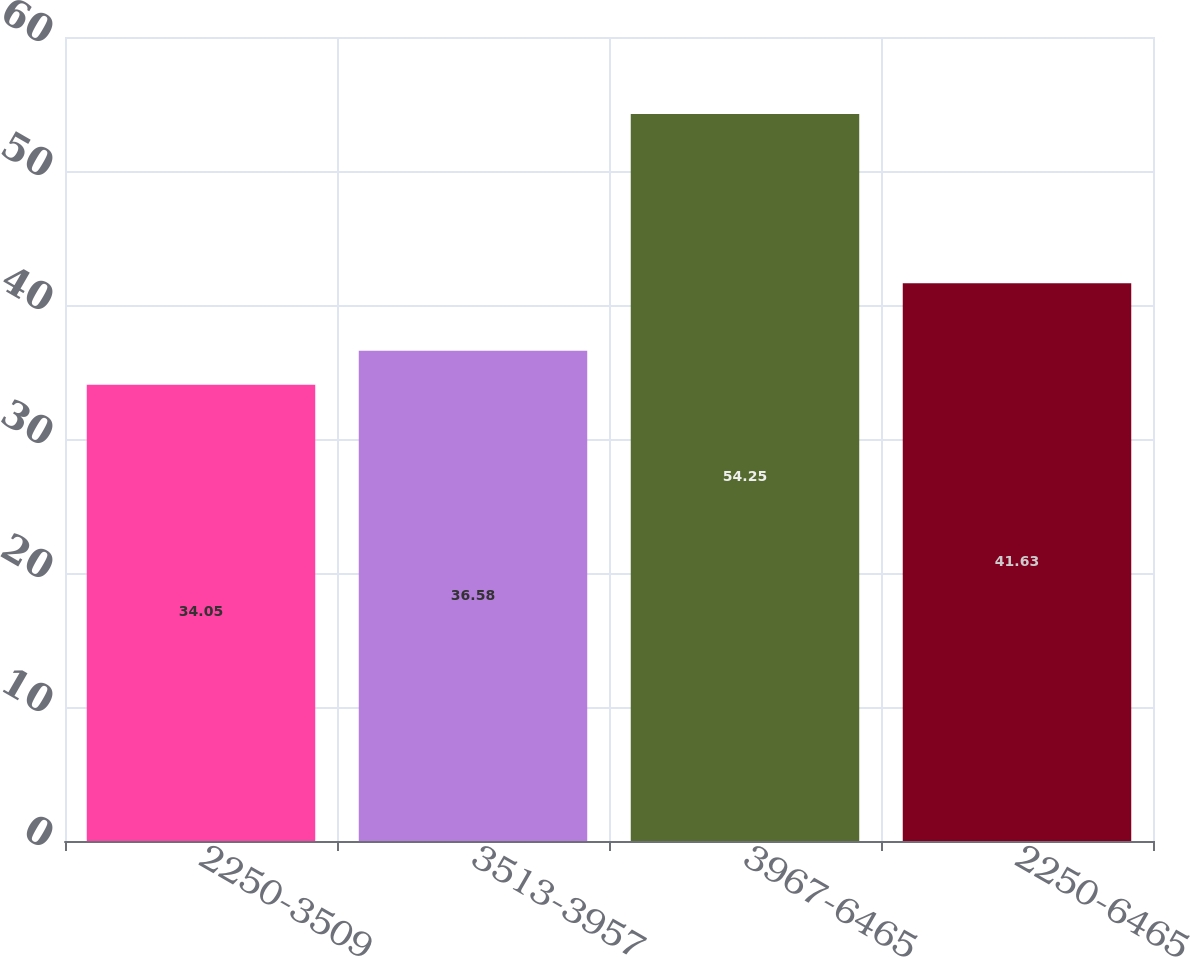<chart> <loc_0><loc_0><loc_500><loc_500><bar_chart><fcel>2250-3509<fcel>3513-3957<fcel>3967-6465<fcel>2250-6465<nl><fcel>34.05<fcel>36.58<fcel>54.25<fcel>41.63<nl></chart> 